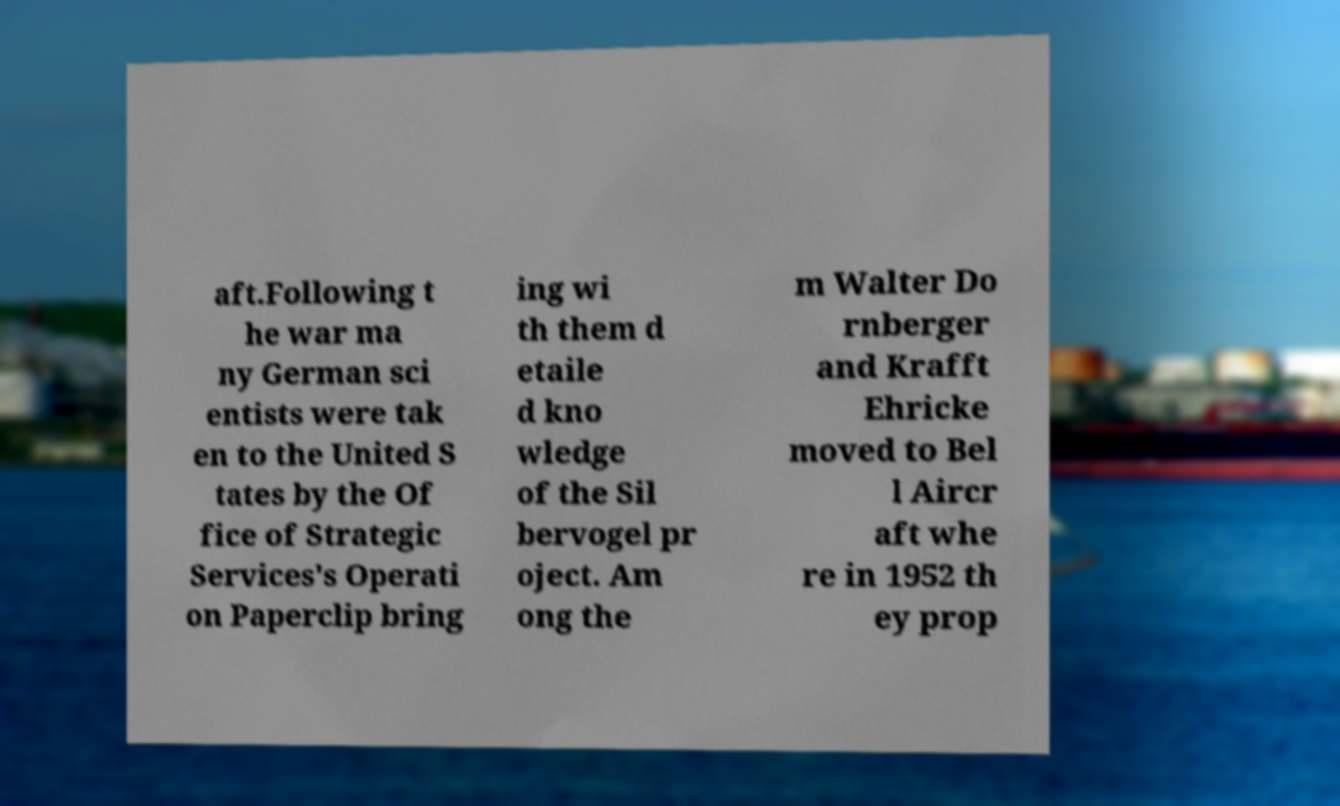What messages or text are displayed in this image? I need them in a readable, typed format. aft.Following t he war ma ny German sci entists were tak en to the United S tates by the Of fice of Strategic Services's Operati on Paperclip bring ing wi th them d etaile d kno wledge of the Sil bervogel pr oject. Am ong the m Walter Do rnberger and Krafft Ehricke moved to Bel l Aircr aft whe re in 1952 th ey prop 